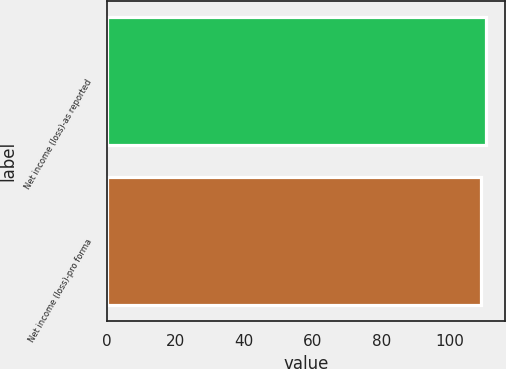Convert chart to OTSL. <chart><loc_0><loc_0><loc_500><loc_500><bar_chart><fcel>Net income (loss)-as reported<fcel>Net income (loss)-pro forma<nl><fcel>110.6<fcel>109<nl></chart> 